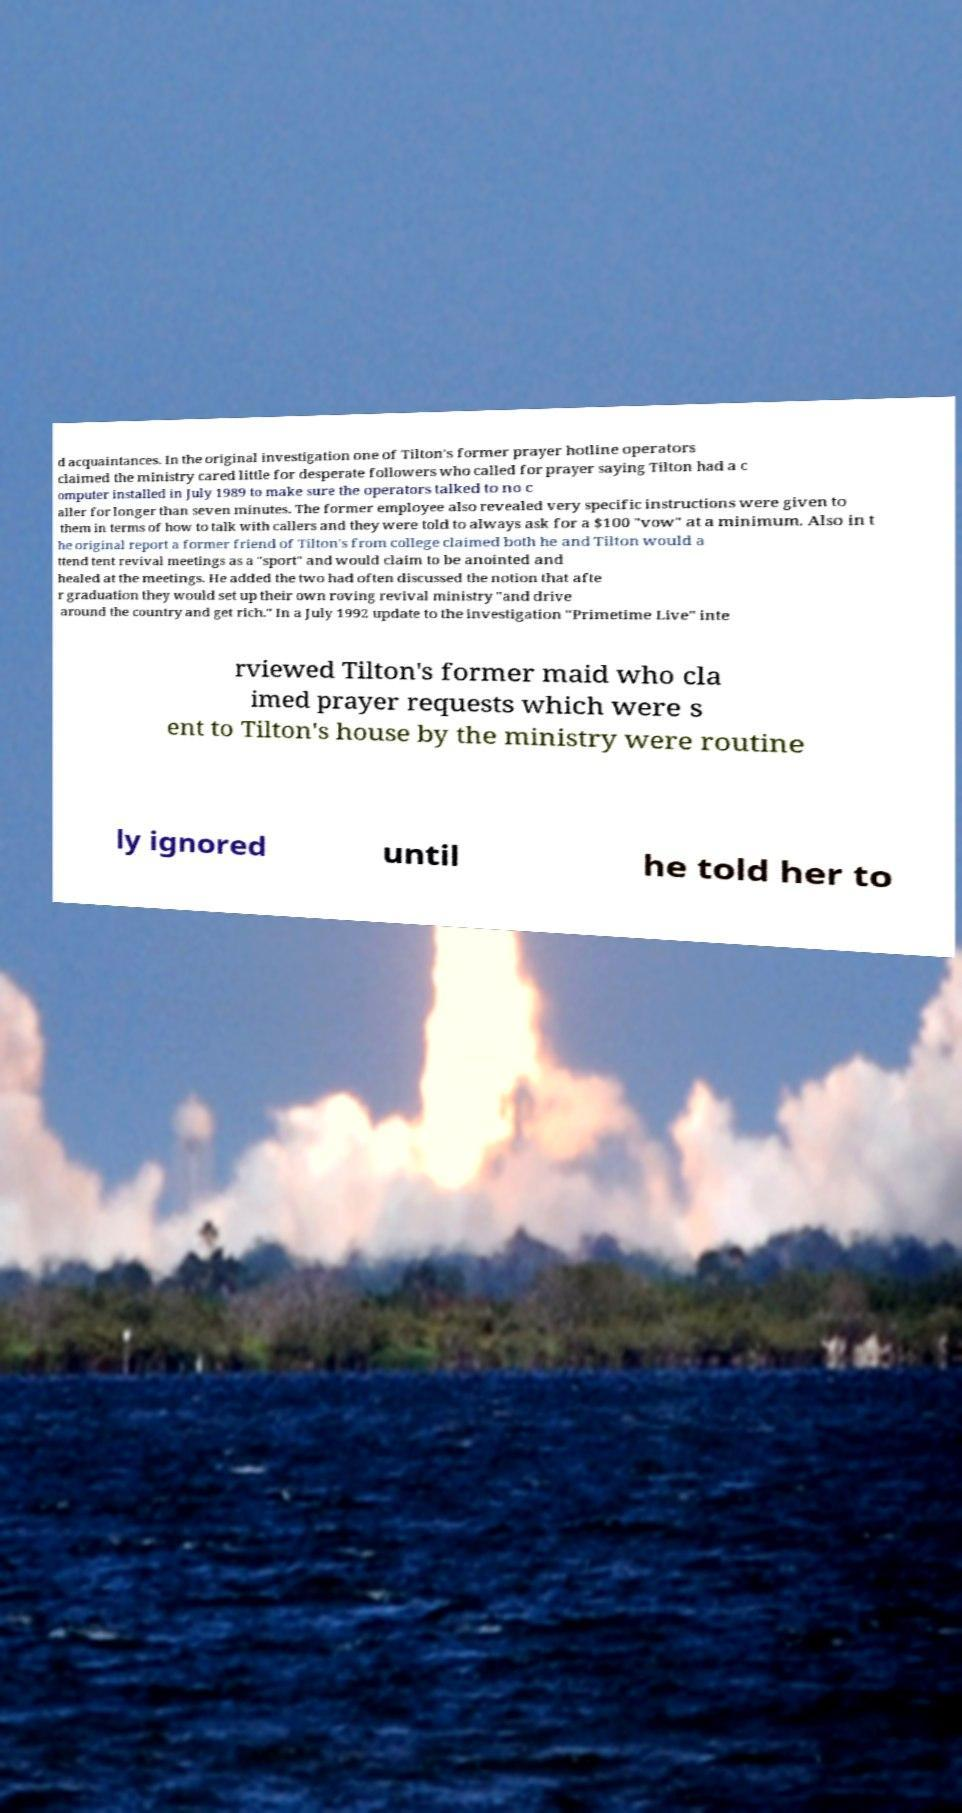For documentation purposes, I need the text within this image transcribed. Could you provide that? d acquaintances. In the original investigation one of Tilton's former prayer hotline operators claimed the ministry cared little for desperate followers who called for prayer saying Tilton had a c omputer installed in July 1989 to make sure the operators talked to no c aller for longer than seven minutes. The former employee also revealed very specific instructions were given to them in terms of how to talk with callers and they were told to always ask for a $100 "vow" at a minimum. Also in t he original report a former friend of Tilton's from college claimed both he and Tilton would a ttend tent revival meetings as a "sport" and would claim to be anointed and healed at the meetings. He added the two had often discussed the notion that afte r graduation they would set up their own roving revival ministry "and drive around the country and get rich." In a July 1992 update to the investigation "Primetime Live" inte rviewed Tilton's former maid who cla imed prayer requests which were s ent to Tilton's house by the ministry were routine ly ignored until he told her to 